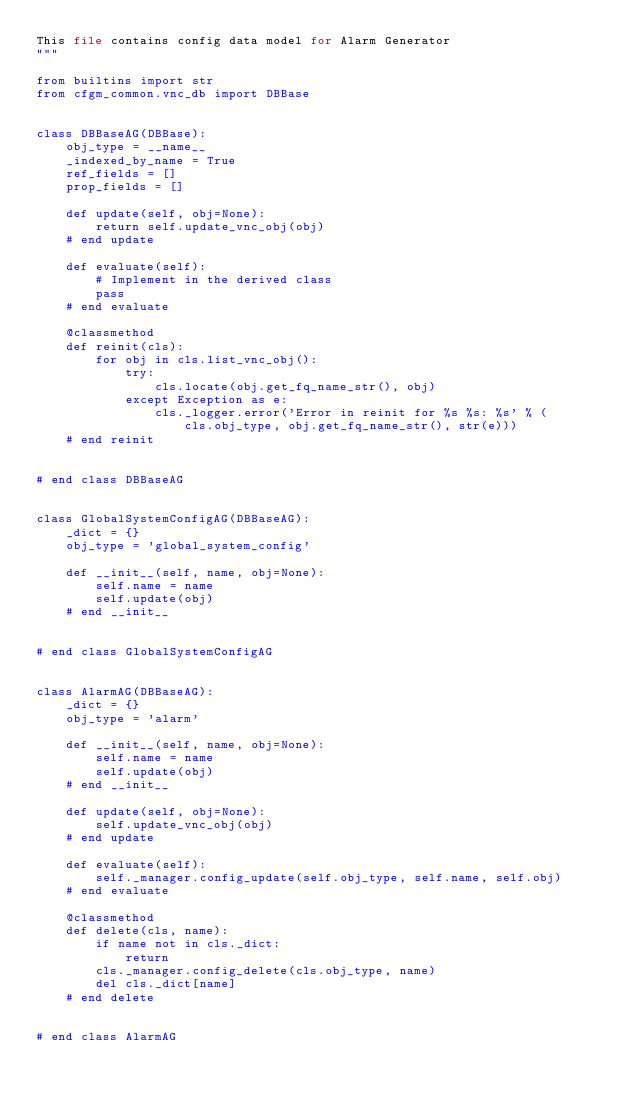<code> <loc_0><loc_0><loc_500><loc_500><_Python_>This file contains config data model for Alarm Generator
"""

from builtins import str
from cfgm_common.vnc_db import DBBase


class DBBaseAG(DBBase):
    obj_type = __name__
    _indexed_by_name = True
    ref_fields = []
    prop_fields = []

    def update(self, obj=None):
        return self.update_vnc_obj(obj)
    # end update

    def evaluate(self):
        # Implement in the derived class
        pass
    # end evaluate

    @classmethod
    def reinit(cls):
        for obj in cls.list_vnc_obj():
            try:
                cls.locate(obj.get_fq_name_str(), obj)
            except Exception as e:
                cls._logger.error('Error in reinit for %s %s: %s' % (
                    cls.obj_type, obj.get_fq_name_str(), str(e)))
    # end reinit


# end class DBBaseAG


class GlobalSystemConfigAG(DBBaseAG):
    _dict = {}
    obj_type = 'global_system_config'

    def __init__(self, name, obj=None):
        self.name = name
        self.update(obj)
    # end __init__


# end class GlobalSystemConfigAG


class AlarmAG(DBBaseAG):
    _dict = {}
    obj_type = 'alarm'

    def __init__(self, name, obj=None):
        self.name = name
        self.update(obj)
    # end __init__

    def update(self, obj=None):
        self.update_vnc_obj(obj)
    # end update

    def evaluate(self):
        self._manager.config_update(self.obj_type, self.name, self.obj)
    # end evaluate

    @classmethod
    def delete(cls, name):
        if name not in cls._dict:
            return
        cls._manager.config_delete(cls.obj_type, name)
        del cls._dict[name]
    # end delete


# end class AlarmAG
</code> 